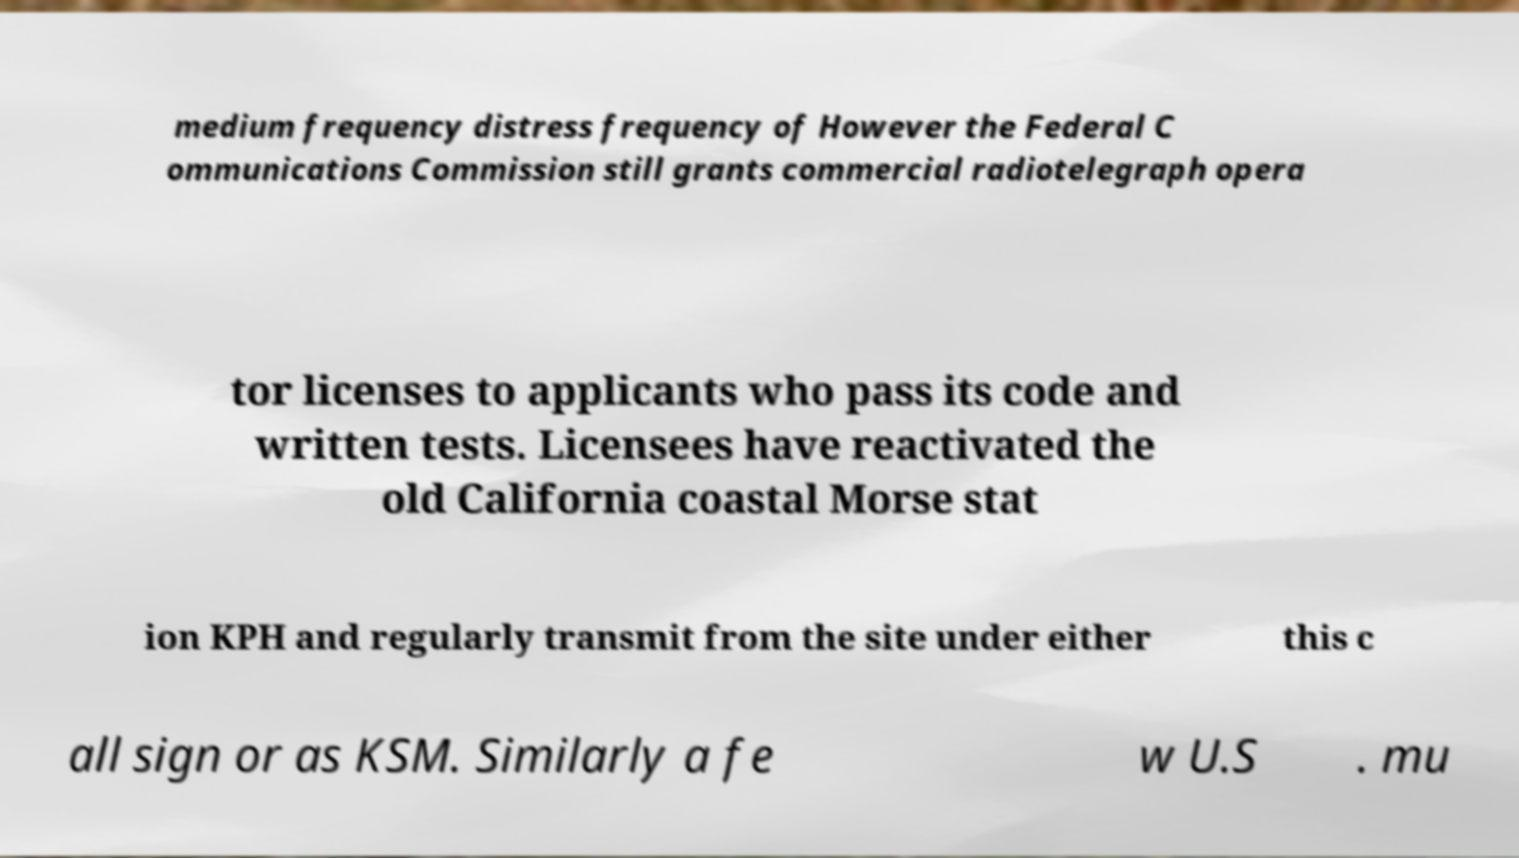Please read and relay the text visible in this image. What does it say? medium frequency distress frequency of However the Federal C ommunications Commission still grants commercial radiotelegraph opera tor licenses to applicants who pass its code and written tests. Licensees have reactivated the old California coastal Morse stat ion KPH and regularly transmit from the site under either this c all sign or as KSM. Similarly a fe w U.S . mu 